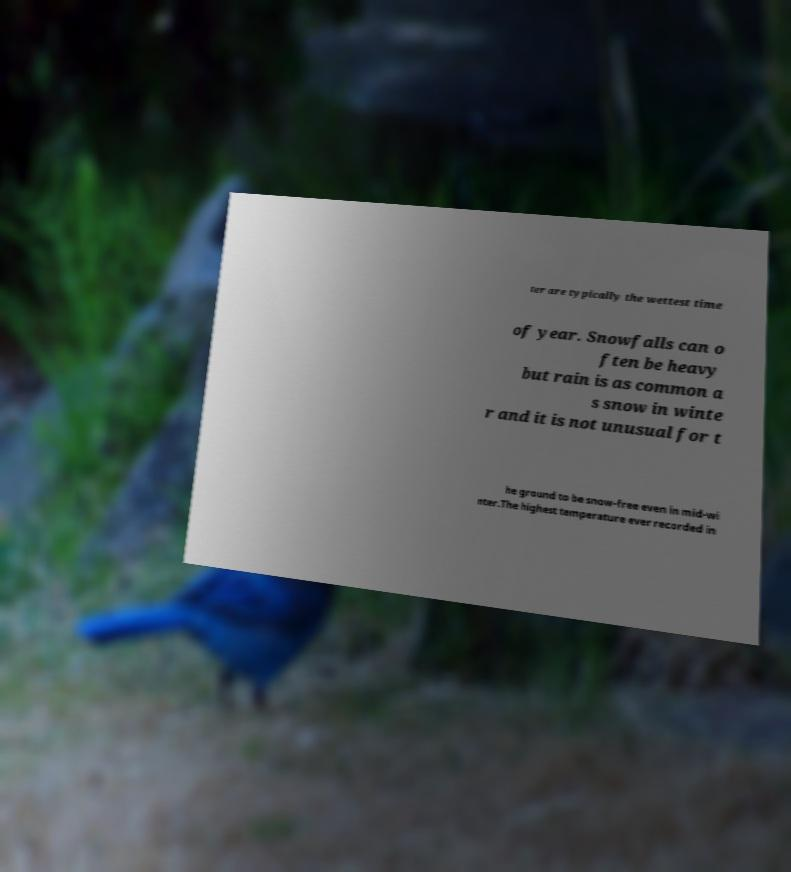Could you assist in decoding the text presented in this image and type it out clearly? ter are typically the wettest time of year. Snowfalls can o ften be heavy but rain is as common a s snow in winte r and it is not unusual for t he ground to be snow-free even in mid-wi nter.The highest temperature ever recorded in 